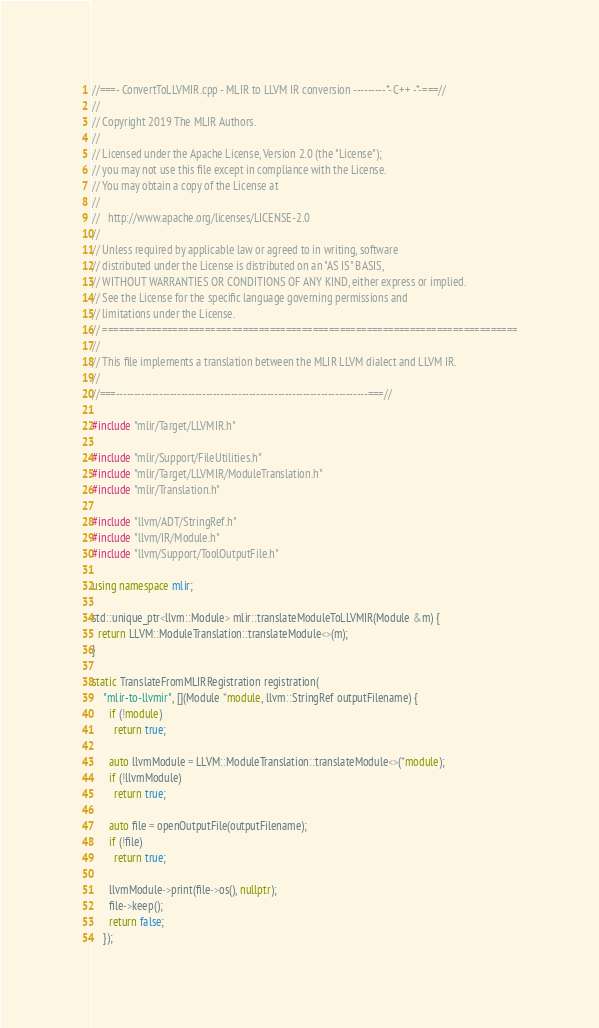Convert code to text. <code><loc_0><loc_0><loc_500><loc_500><_C++_>//===- ConvertToLLVMIR.cpp - MLIR to LLVM IR conversion ---------*- C++ -*-===//
//
// Copyright 2019 The MLIR Authors.
//
// Licensed under the Apache License, Version 2.0 (the "License");
// you may not use this file except in compliance with the License.
// You may obtain a copy of the License at
//
//   http://www.apache.org/licenses/LICENSE-2.0
//
// Unless required by applicable law or agreed to in writing, software
// distributed under the License is distributed on an "AS IS" BASIS,
// WITHOUT WARRANTIES OR CONDITIONS OF ANY KIND, either express or implied.
// See the License for the specific language governing permissions and
// limitations under the License.
// =============================================================================
//
// This file implements a translation between the MLIR LLVM dialect and LLVM IR.
//
//===----------------------------------------------------------------------===//

#include "mlir/Target/LLVMIR.h"

#include "mlir/Support/FileUtilities.h"
#include "mlir/Target/LLVMIR/ModuleTranslation.h"
#include "mlir/Translation.h"

#include "llvm/ADT/StringRef.h"
#include "llvm/IR/Module.h"
#include "llvm/Support/ToolOutputFile.h"

using namespace mlir;

std::unique_ptr<llvm::Module> mlir::translateModuleToLLVMIR(Module &m) {
  return LLVM::ModuleTranslation::translateModule<>(m);
}

static TranslateFromMLIRRegistration registration(
    "mlir-to-llvmir", [](Module *module, llvm::StringRef outputFilename) {
      if (!module)
        return true;

      auto llvmModule = LLVM::ModuleTranslation::translateModule<>(*module);
      if (!llvmModule)
        return true;

      auto file = openOutputFile(outputFilename);
      if (!file)
        return true;

      llvmModule->print(file->os(), nullptr);
      file->keep();
      return false;
    });
</code> 